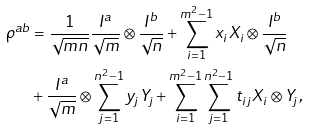Convert formula to latex. <formula><loc_0><loc_0><loc_500><loc_500>\rho ^ { a b } & = \frac { 1 } { \sqrt { m n } } \frac { I ^ { a } } { \sqrt { m } } \otimes \frac { I ^ { b } } { \sqrt { n } } + \sum _ { i = 1 } ^ { m ^ { 2 } - 1 } x _ { i } X _ { i } \otimes \frac { I ^ { b } } { \sqrt { n } } \\ & + \frac { I ^ { a } } { \sqrt { m } } \otimes \sum _ { j = 1 } ^ { n ^ { 2 } - 1 } y _ { j } Y _ { j } + \sum _ { i = 1 } ^ { m ^ { 2 } - 1 } \sum _ { j = 1 } ^ { n ^ { 2 } - 1 } t _ { i j } X _ { i } \otimes Y _ { j } ,</formula> 